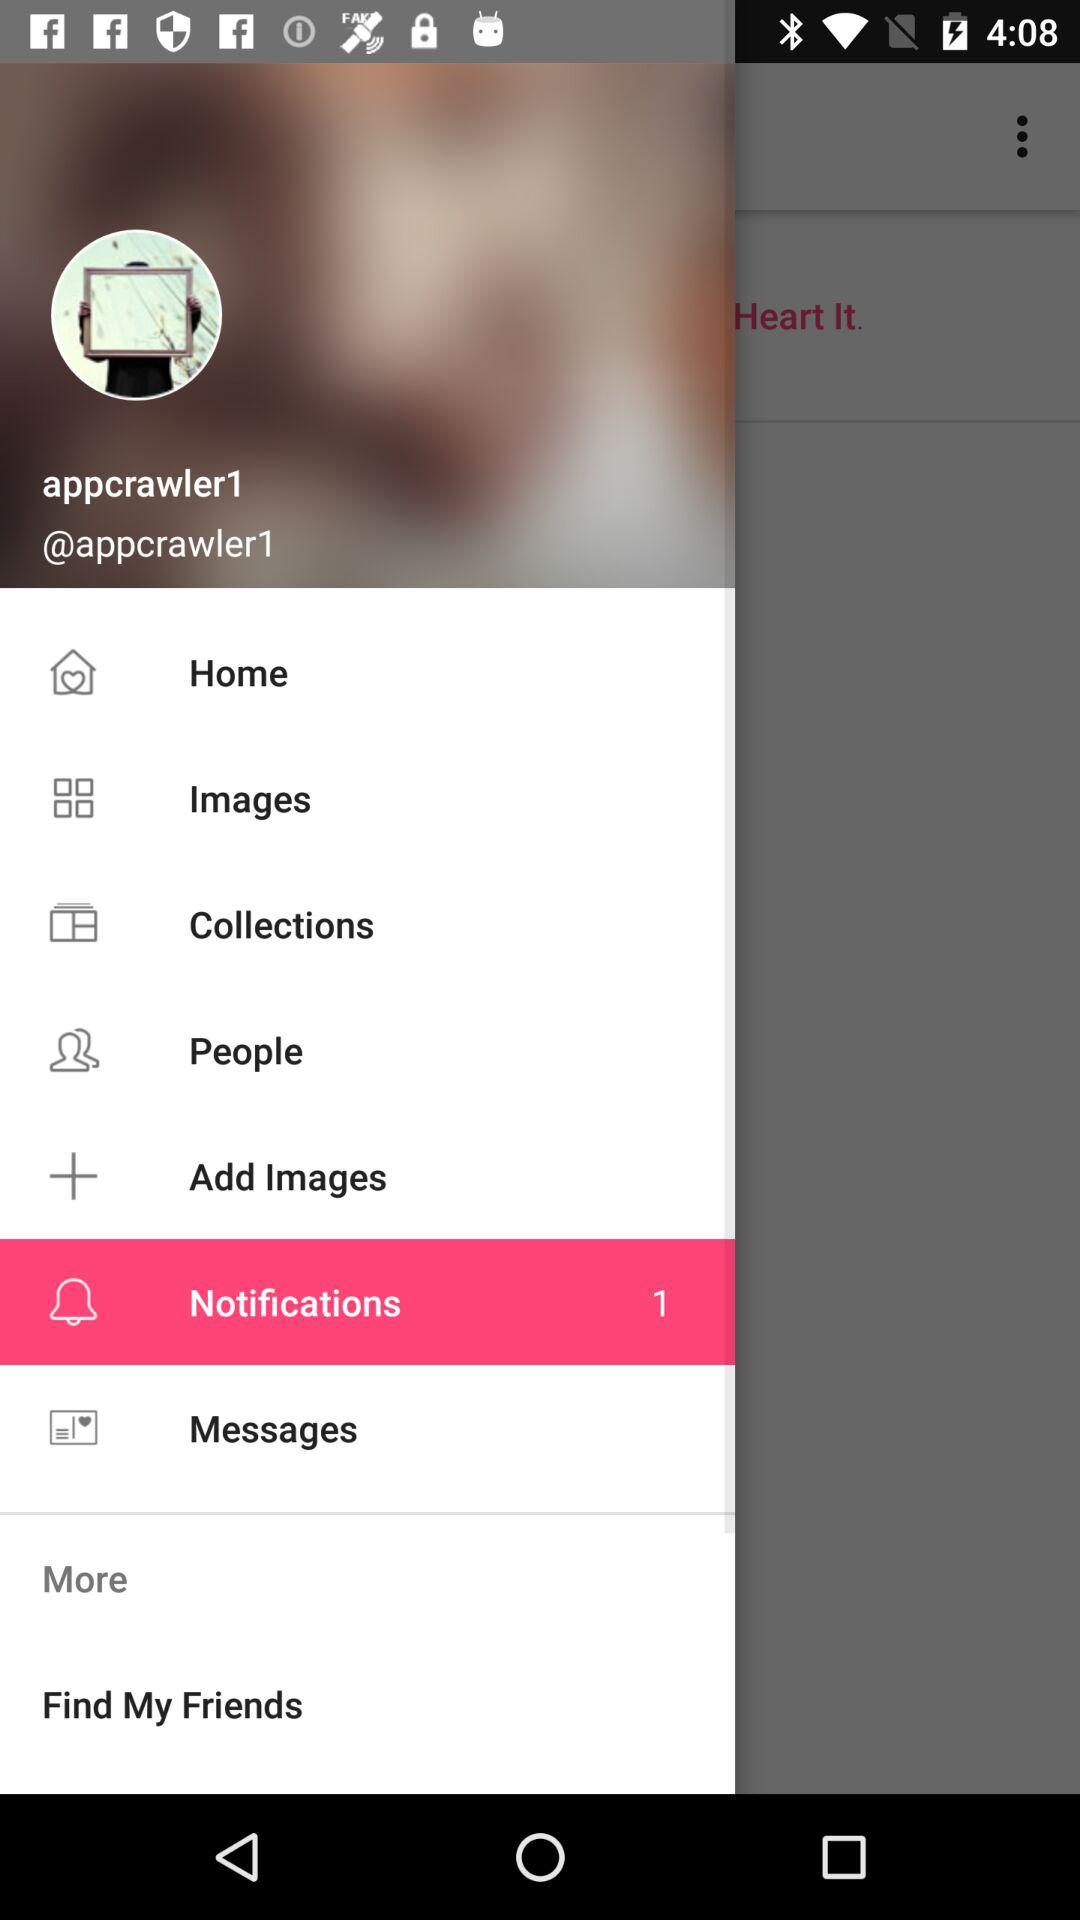How many notifications are unread? There is 1 unread notification. 